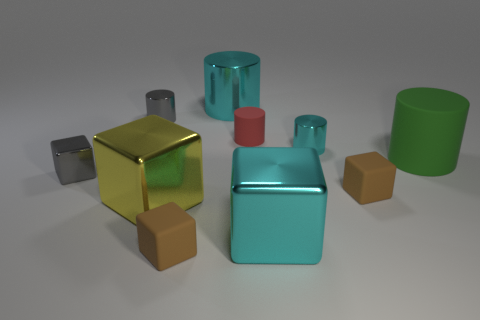Subtract all big yellow metallic cubes. How many cubes are left? 4 Subtract all green cylinders. How many cylinders are left? 4 Add 3 green rubber cylinders. How many green rubber cylinders are left? 4 Add 9 purple metal cubes. How many purple metal cubes exist? 9 Subtract 0 purple spheres. How many objects are left? 10 Subtract 3 cylinders. How many cylinders are left? 2 Subtract all brown cylinders. Subtract all red spheres. How many cylinders are left? 5 Subtract all red balls. How many brown cubes are left? 2 Subtract all big metallic blocks. Subtract all shiny cylinders. How many objects are left? 5 